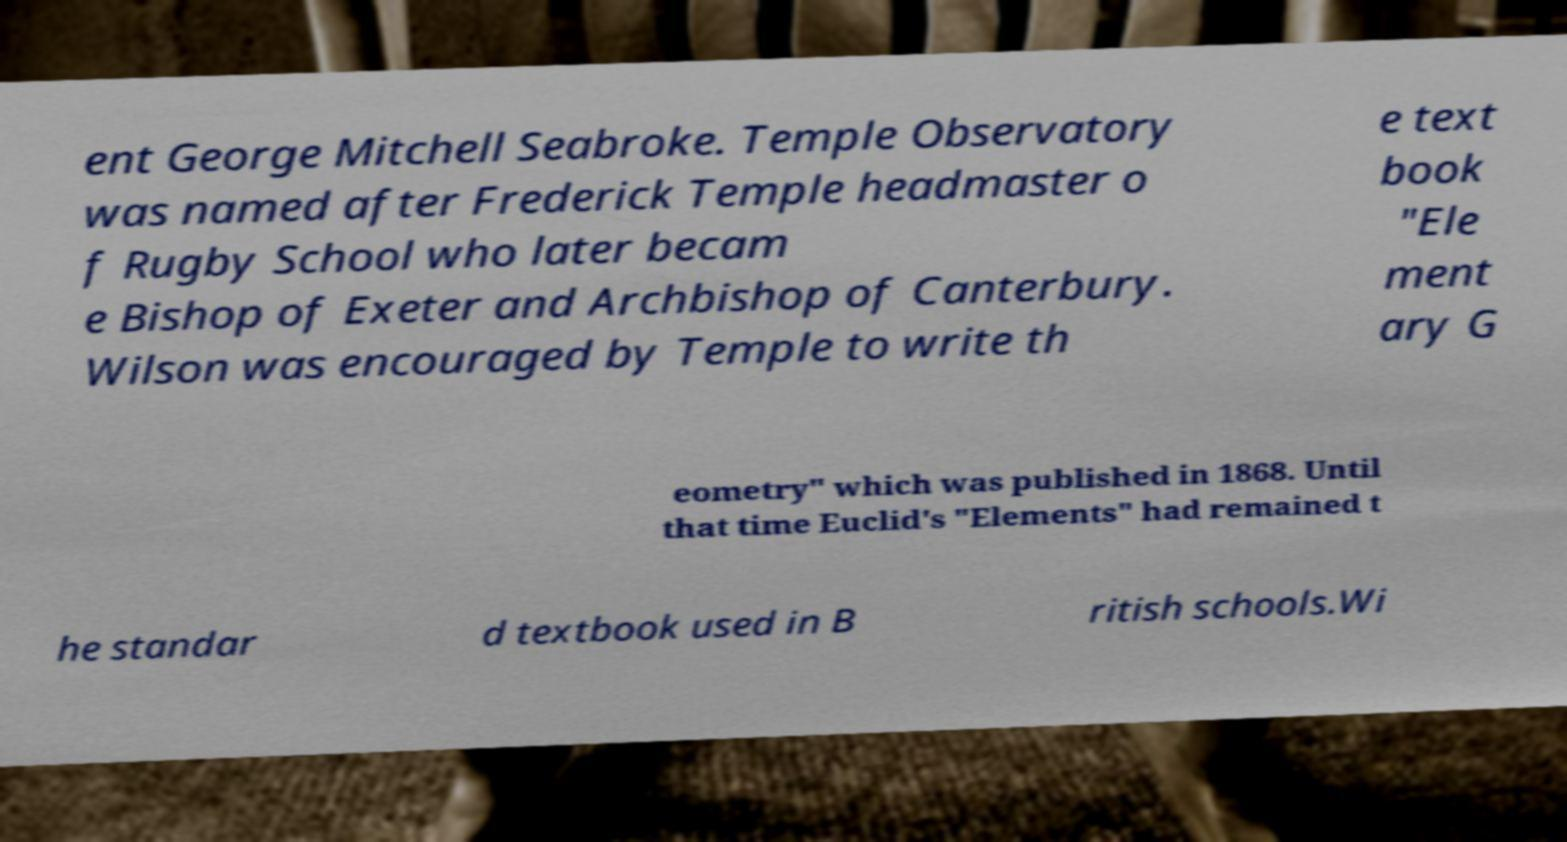Could you assist in decoding the text presented in this image and type it out clearly? ent George Mitchell Seabroke. Temple Observatory was named after Frederick Temple headmaster o f Rugby School who later becam e Bishop of Exeter and Archbishop of Canterbury. Wilson was encouraged by Temple to write th e text book "Ele ment ary G eometry" which was published in 1868. Until that time Euclid's "Elements" had remained t he standar d textbook used in B ritish schools.Wi 